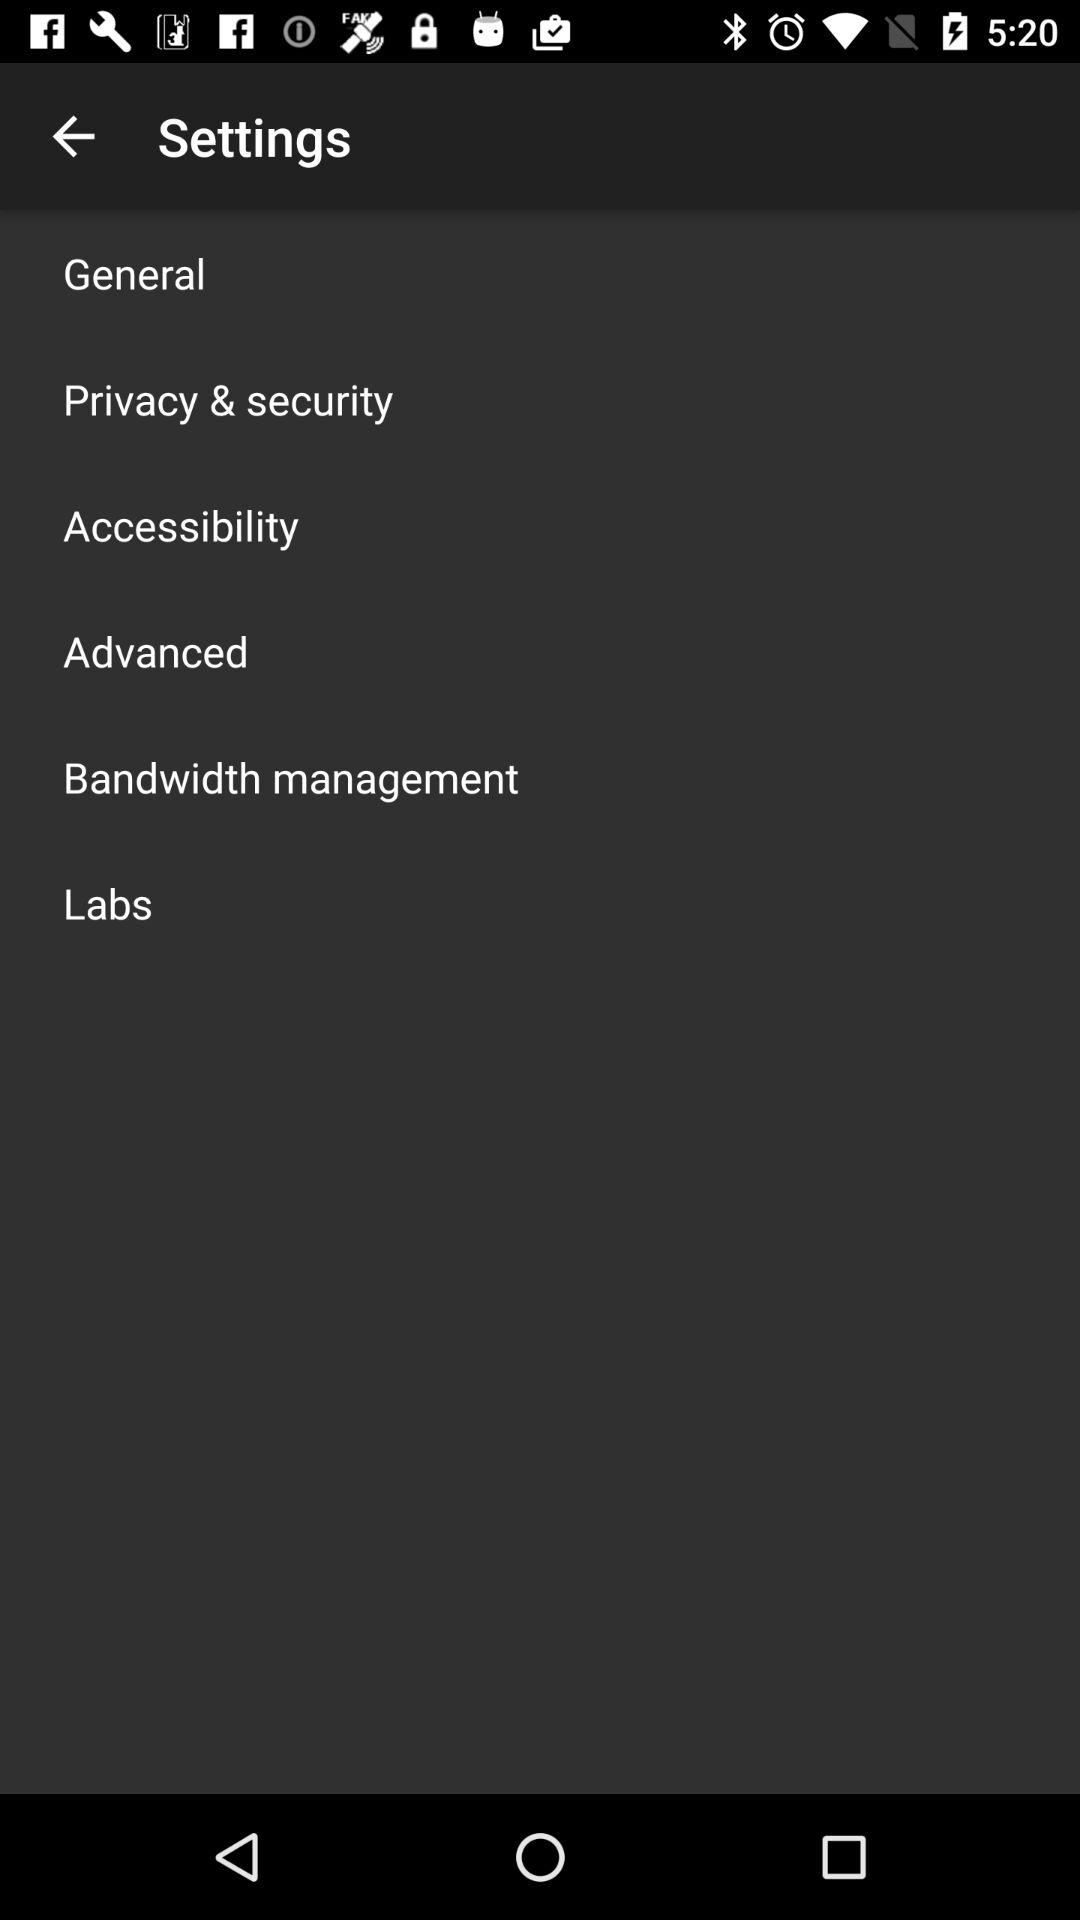How many settings sub-categories are there?
Answer the question using a single word or phrase. 6 